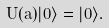<formula> <loc_0><loc_0><loc_500><loc_500>U ( a ) | 0 \rangle = | 0 \rangle .</formula> 